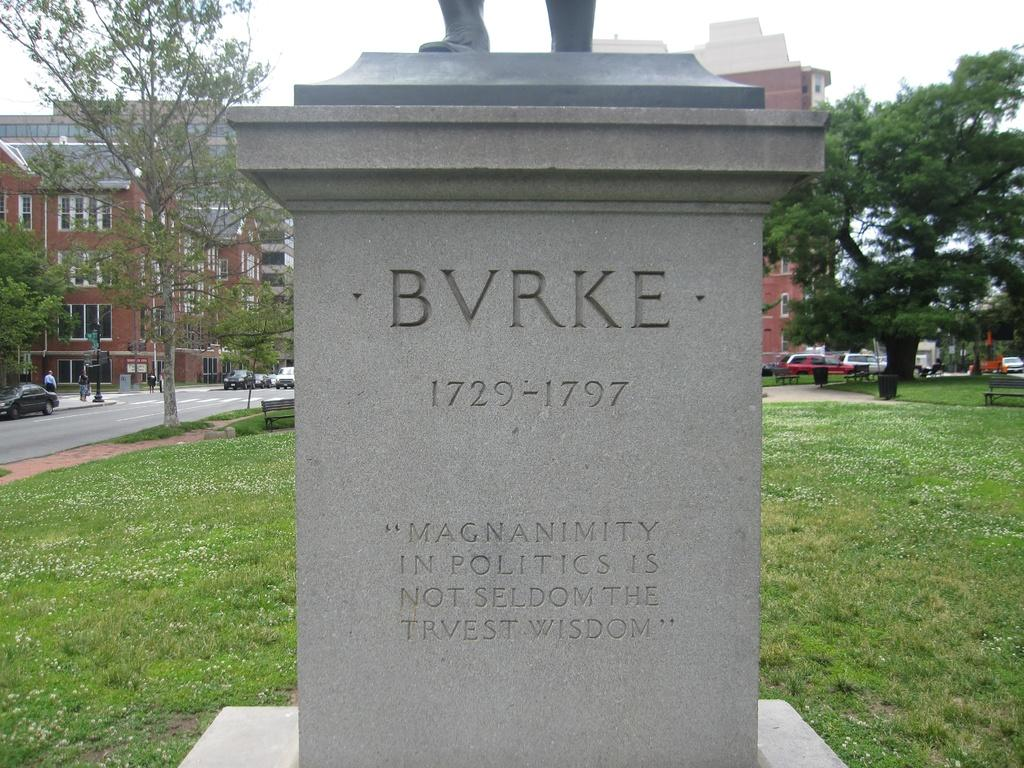What is the main subject in the image? There is a statue in the image. What is written on the block near the statue? There is text on a block in the image. What can be used for sitting in the image? There are benches in the image. Where is the bin located in the image? The bin is on the grass in the image. What type of structure is visible in the image? There is a building in the image. What can be seen moving in the image? There are vehicles in the image. Who or what is present in the image? There are people in the image. What are the poles used for in the image? The poles are present in the image, but their purpose is not specified. What is visible in the background of the image? The sky is visible in the image. What type of advertisement can be seen on the statue in the image? There is no advertisement present on the statue in the image. What letters are visible on the statue in the image? There are no letters visible on the statue in the image. 